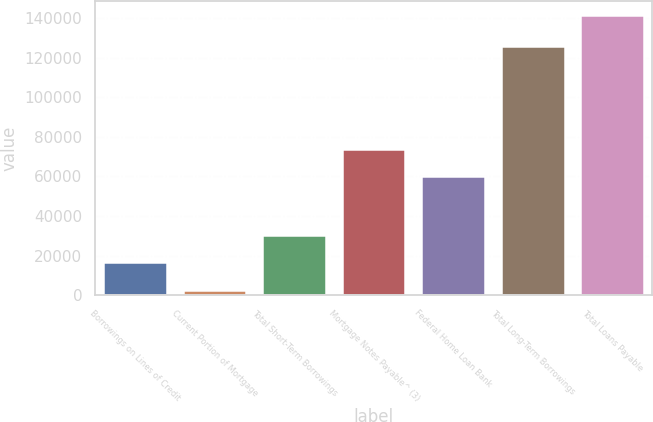Convert chart to OTSL. <chart><loc_0><loc_0><loc_500><loc_500><bar_chart><fcel>Borrowings on Lines of Credit<fcel>Current Portion of Mortgage<fcel>Total Short-Term Borrowings<fcel>Mortgage Notes Payable^ (3)<fcel>Federal Home Loan Bank<fcel>Total Long-Term Borrowings<fcel>Total Loans Payable<nl><fcel>16635.2<fcel>2746<fcel>30524.4<fcel>73889.2<fcel>60000<fcel>125852<fcel>141638<nl></chart> 